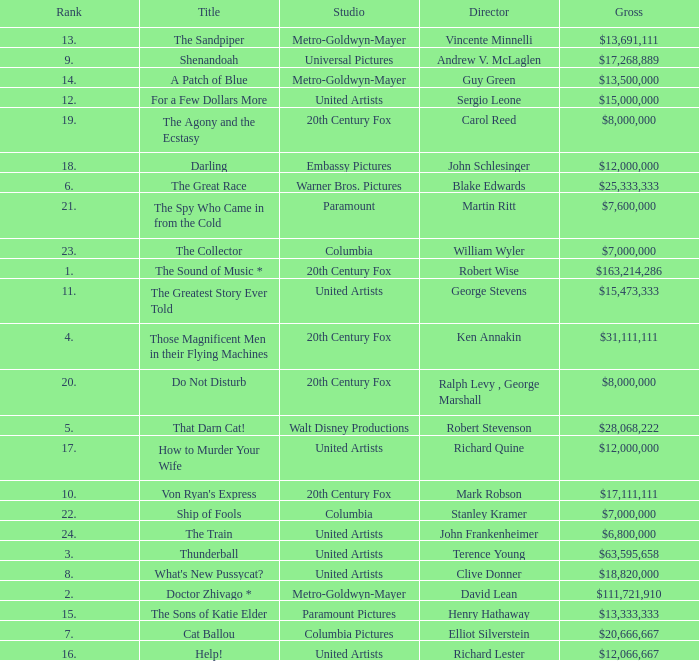What is Studio, when Title is "Do Not Disturb"? 20th Century Fox. 